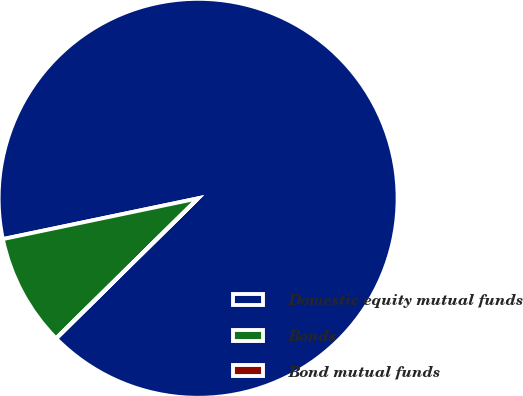Convert chart to OTSL. <chart><loc_0><loc_0><loc_500><loc_500><pie_chart><fcel>Domestic equity mutual funds<fcel>Bonds<fcel>Bond mutual funds<nl><fcel>90.88%<fcel>9.11%<fcel>0.02%<nl></chart> 